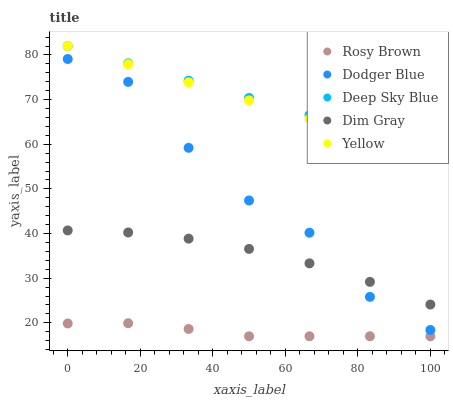Does Rosy Brown have the minimum area under the curve?
Answer yes or no. Yes. Does Deep Sky Blue have the maximum area under the curve?
Answer yes or no. Yes. Does Dodger Blue have the minimum area under the curve?
Answer yes or no. No. Does Dodger Blue have the maximum area under the curve?
Answer yes or no. No. Is Yellow the smoothest?
Answer yes or no. Yes. Is Dodger Blue the roughest?
Answer yes or no. Yes. Is Rosy Brown the smoothest?
Answer yes or no. No. Is Rosy Brown the roughest?
Answer yes or no. No. Does Rosy Brown have the lowest value?
Answer yes or no. Yes. Does Dodger Blue have the lowest value?
Answer yes or no. No. Does Deep Sky Blue have the highest value?
Answer yes or no. Yes. Does Dodger Blue have the highest value?
Answer yes or no. No. Is Dim Gray less than Deep Sky Blue?
Answer yes or no. Yes. Is Deep Sky Blue greater than Dodger Blue?
Answer yes or no. Yes. Does Dodger Blue intersect Dim Gray?
Answer yes or no. Yes. Is Dodger Blue less than Dim Gray?
Answer yes or no. No. Is Dodger Blue greater than Dim Gray?
Answer yes or no. No. Does Dim Gray intersect Deep Sky Blue?
Answer yes or no. No. 